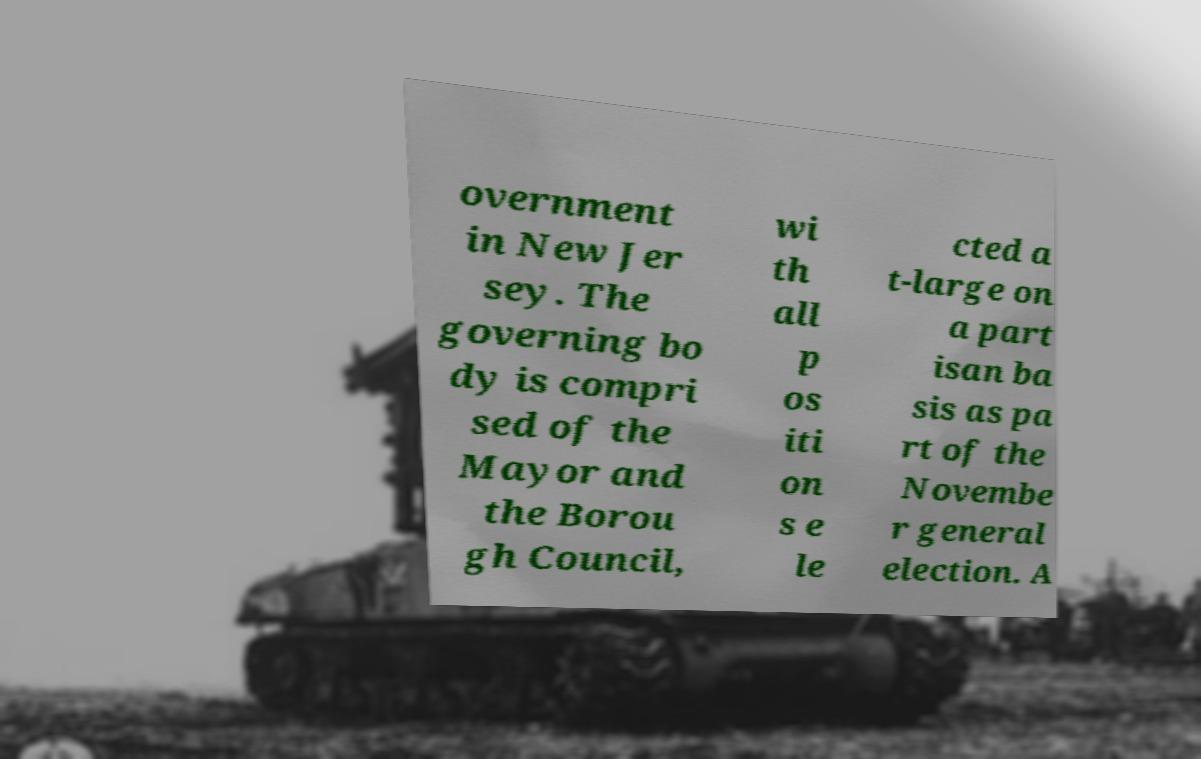Can you accurately transcribe the text from the provided image for me? overnment in New Jer sey. The governing bo dy is compri sed of the Mayor and the Borou gh Council, wi th all p os iti on s e le cted a t-large on a part isan ba sis as pa rt of the Novembe r general election. A 